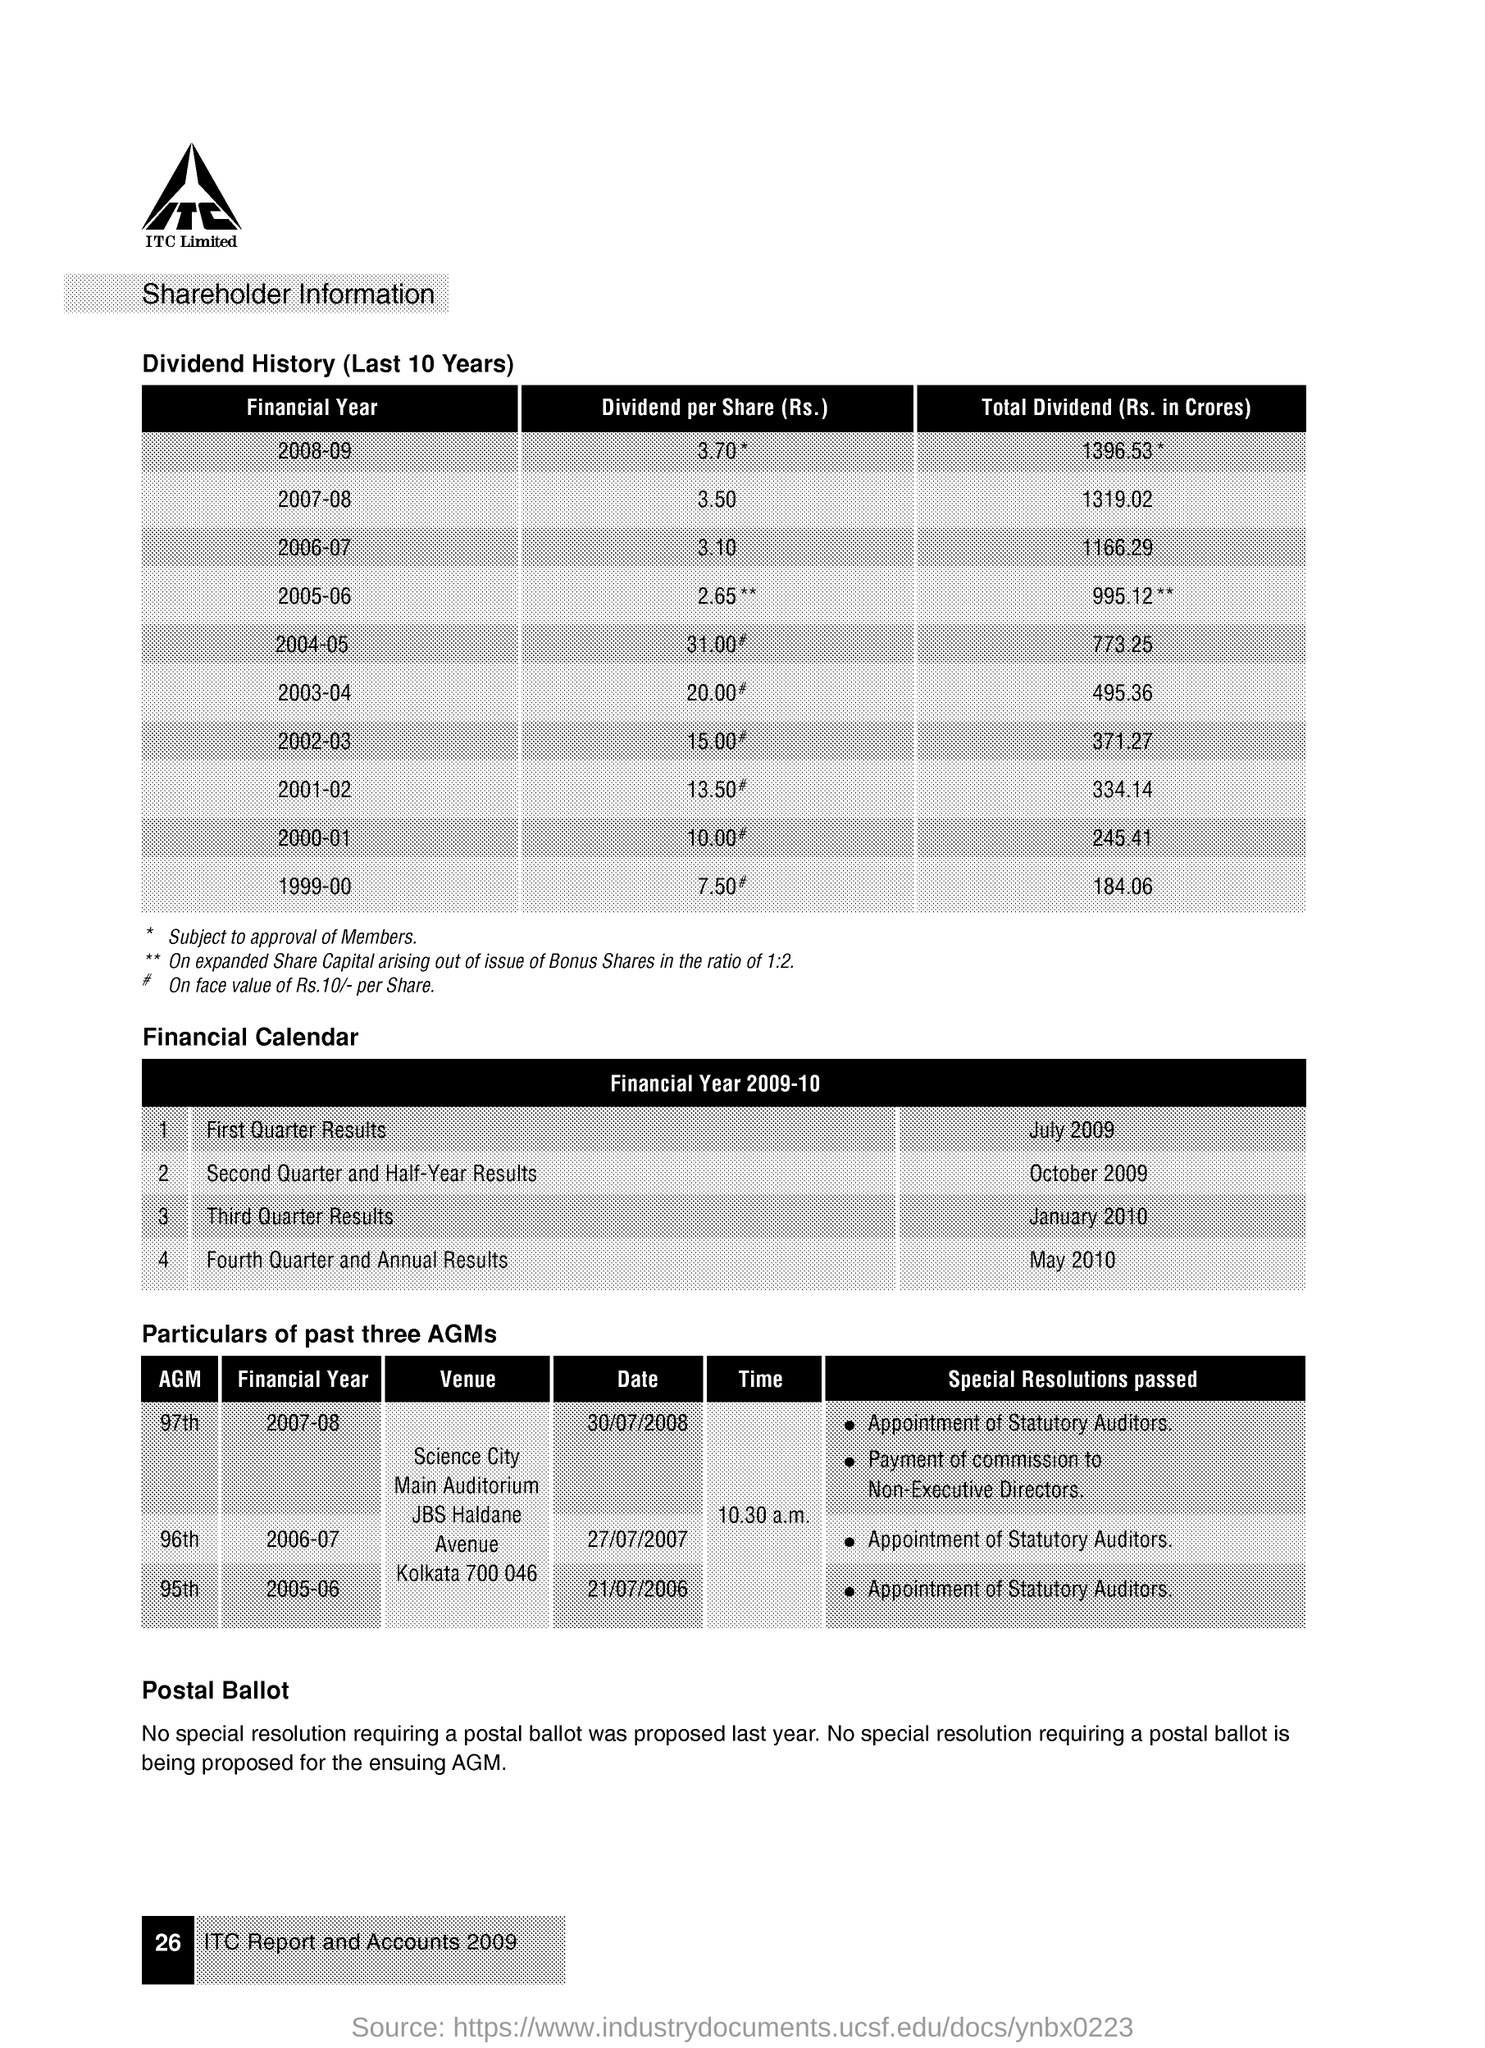What's the trend in the dividend per share over the last 10 years as seen in the image? The trend in dividend per share from the financial year 1999-00 to 2008-09 shows a general increase, with a notable peak in 2004-05 when the dividend per share was 31.00 Rs, attributable to expanded share capital arising out of the issue of Bonus Shares in the ratio of 1:2. 